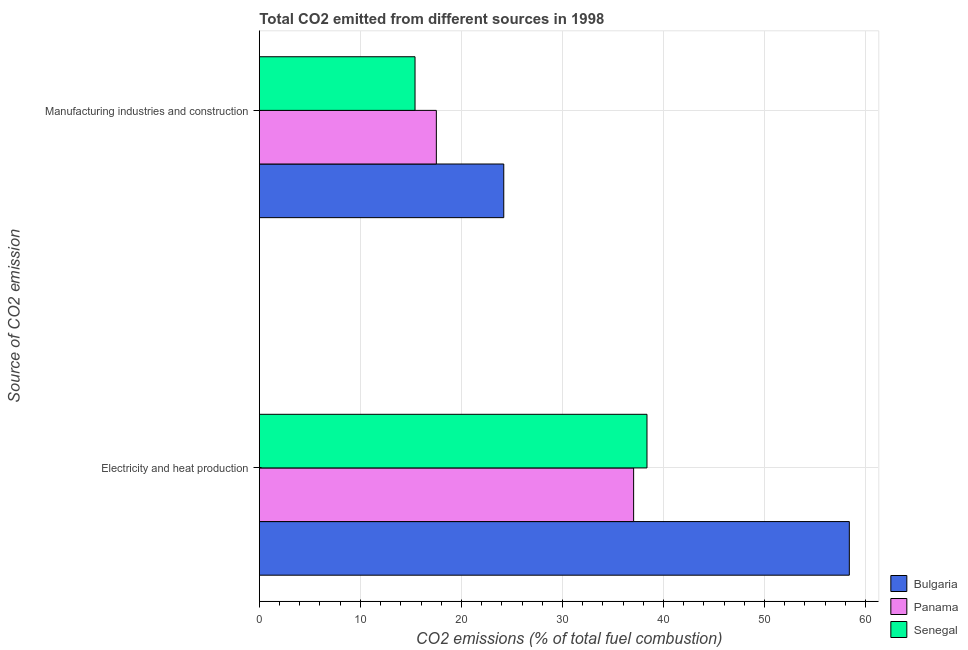Are the number of bars on each tick of the Y-axis equal?
Ensure brevity in your answer.  Yes. How many bars are there on the 2nd tick from the top?
Provide a succinct answer. 3. What is the label of the 2nd group of bars from the top?
Offer a very short reply. Electricity and heat production. What is the co2 emissions due to electricity and heat production in Senegal?
Provide a succinct answer. 38.36. Across all countries, what is the maximum co2 emissions due to electricity and heat production?
Provide a short and direct response. 58.39. Across all countries, what is the minimum co2 emissions due to manufacturing industries?
Your response must be concise. 15.41. In which country was the co2 emissions due to electricity and heat production maximum?
Your answer should be compact. Bulgaria. In which country was the co2 emissions due to manufacturing industries minimum?
Make the answer very short. Senegal. What is the total co2 emissions due to electricity and heat production in the graph?
Ensure brevity in your answer.  133.8. What is the difference between the co2 emissions due to electricity and heat production in Senegal and that in Panama?
Your response must be concise. 1.32. What is the difference between the co2 emissions due to manufacturing industries in Bulgaria and the co2 emissions due to electricity and heat production in Panama?
Keep it short and to the point. -12.85. What is the average co2 emissions due to manufacturing industries per country?
Give a very brief answer. 19.04. What is the difference between the co2 emissions due to manufacturing industries and co2 emissions due to electricity and heat production in Senegal?
Your answer should be very brief. -22.96. What is the ratio of the co2 emissions due to manufacturing industries in Panama to that in Senegal?
Offer a terse response. 1.14. In how many countries, is the co2 emissions due to electricity and heat production greater than the average co2 emissions due to electricity and heat production taken over all countries?
Provide a short and direct response. 1. What does the 1st bar from the top in Electricity and heat production represents?
Offer a very short reply. Senegal. What does the 1st bar from the bottom in Electricity and heat production represents?
Provide a succinct answer. Bulgaria. How many bars are there?
Offer a terse response. 6. How many countries are there in the graph?
Provide a succinct answer. 3. What is the difference between two consecutive major ticks on the X-axis?
Ensure brevity in your answer.  10. Are the values on the major ticks of X-axis written in scientific E-notation?
Ensure brevity in your answer.  No. How are the legend labels stacked?
Provide a succinct answer. Vertical. What is the title of the graph?
Your answer should be very brief. Total CO2 emitted from different sources in 1998. What is the label or title of the X-axis?
Provide a short and direct response. CO2 emissions (% of total fuel combustion). What is the label or title of the Y-axis?
Make the answer very short. Source of CO2 emission. What is the CO2 emissions (% of total fuel combustion) in Bulgaria in Electricity and heat production?
Provide a succinct answer. 58.39. What is the CO2 emissions (% of total fuel combustion) of Panama in Electricity and heat production?
Keep it short and to the point. 37.04. What is the CO2 emissions (% of total fuel combustion) of Senegal in Electricity and heat production?
Your answer should be very brief. 38.36. What is the CO2 emissions (% of total fuel combustion) in Bulgaria in Manufacturing industries and construction?
Your answer should be compact. 24.19. What is the CO2 emissions (% of total fuel combustion) in Panama in Manufacturing industries and construction?
Provide a succinct answer. 17.52. What is the CO2 emissions (% of total fuel combustion) of Senegal in Manufacturing industries and construction?
Offer a very short reply. 15.41. Across all Source of CO2 emission, what is the maximum CO2 emissions (% of total fuel combustion) of Bulgaria?
Your response must be concise. 58.39. Across all Source of CO2 emission, what is the maximum CO2 emissions (% of total fuel combustion) in Panama?
Your response must be concise. 37.04. Across all Source of CO2 emission, what is the maximum CO2 emissions (% of total fuel combustion) of Senegal?
Your answer should be very brief. 38.36. Across all Source of CO2 emission, what is the minimum CO2 emissions (% of total fuel combustion) of Bulgaria?
Keep it short and to the point. 24.19. Across all Source of CO2 emission, what is the minimum CO2 emissions (% of total fuel combustion) of Panama?
Your answer should be compact. 17.52. Across all Source of CO2 emission, what is the minimum CO2 emissions (% of total fuel combustion) in Senegal?
Your answer should be very brief. 15.41. What is the total CO2 emissions (% of total fuel combustion) in Bulgaria in the graph?
Offer a very short reply. 82.58. What is the total CO2 emissions (% of total fuel combustion) in Panama in the graph?
Provide a succinct answer. 54.56. What is the total CO2 emissions (% of total fuel combustion) of Senegal in the graph?
Your response must be concise. 53.77. What is the difference between the CO2 emissions (% of total fuel combustion) in Bulgaria in Electricity and heat production and that in Manufacturing industries and construction?
Keep it short and to the point. 34.2. What is the difference between the CO2 emissions (% of total fuel combustion) in Panama in Electricity and heat production and that in Manufacturing industries and construction?
Provide a short and direct response. 19.53. What is the difference between the CO2 emissions (% of total fuel combustion) in Senegal in Electricity and heat production and that in Manufacturing industries and construction?
Provide a short and direct response. 22.96. What is the difference between the CO2 emissions (% of total fuel combustion) in Bulgaria in Electricity and heat production and the CO2 emissions (% of total fuel combustion) in Panama in Manufacturing industries and construction?
Provide a succinct answer. 40.87. What is the difference between the CO2 emissions (% of total fuel combustion) in Bulgaria in Electricity and heat production and the CO2 emissions (% of total fuel combustion) in Senegal in Manufacturing industries and construction?
Ensure brevity in your answer.  42.98. What is the difference between the CO2 emissions (% of total fuel combustion) of Panama in Electricity and heat production and the CO2 emissions (% of total fuel combustion) of Senegal in Manufacturing industries and construction?
Your response must be concise. 21.64. What is the average CO2 emissions (% of total fuel combustion) of Bulgaria per Source of CO2 emission?
Your response must be concise. 41.29. What is the average CO2 emissions (% of total fuel combustion) of Panama per Source of CO2 emission?
Give a very brief answer. 27.28. What is the average CO2 emissions (% of total fuel combustion) of Senegal per Source of CO2 emission?
Your answer should be very brief. 26.89. What is the difference between the CO2 emissions (% of total fuel combustion) of Bulgaria and CO2 emissions (% of total fuel combustion) of Panama in Electricity and heat production?
Offer a terse response. 21.35. What is the difference between the CO2 emissions (% of total fuel combustion) in Bulgaria and CO2 emissions (% of total fuel combustion) in Senegal in Electricity and heat production?
Make the answer very short. 20.03. What is the difference between the CO2 emissions (% of total fuel combustion) in Panama and CO2 emissions (% of total fuel combustion) in Senegal in Electricity and heat production?
Offer a terse response. -1.32. What is the difference between the CO2 emissions (% of total fuel combustion) in Bulgaria and CO2 emissions (% of total fuel combustion) in Panama in Manufacturing industries and construction?
Make the answer very short. 6.67. What is the difference between the CO2 emissions (% of total fuel combustion) in Bulgaria and CO2 emissions (% of total fuel combustion) in Senegal in Manufacturing industries and construction?
Your answer should be very brief. 8.78. What is the difference between the CO2 emissions (% of total fuel combustion) in Panama and CO2 emissions (% of total fuel combustion) in Senegal in Manufacturing industries and construction?
Ensure brevity in your answer.  2.11. What is the ratio of the CO2 emissions (% of total fuel combustion) in Bulgaria in Electricity and heat production to that in Manufacturing industries and construction?
Give a very brief answer. 2.41. What is the ratio of the CO2 emissions (% of total fuel combustion) in Panama in Electricity and heat production to that in Manufacturing industries and construction?
Provide a succinct answer. 2.11. What is the ratio of the CO2 emissions (% of total fuel combustion) in Senegal in Electricity and heat production to that in Manufacturing industries and construction?
Your response must be concise. 2.49. What is the difference between the highest and the second highest CO2 emissions (% of total fuel combustion) in Bulgaria?
Offer a very short reply. 34.2. What is the difference between the highest and the second highest CO2 emissions (% of total fuel combustion) in Panama?
Your answer should be compact. 19.53. What is the difference between the highest and the second highest CO2 emissions (% of total fuel combustion) in Senegal?
Offer a very short reply. 22.96. What is the difference between the highest and the lowest CO2 emissions (% of total fuel combustion) in Bulgaria?
Your answer should be very brief. 34.2. What is the difference between the highest and the lowest CO2 emissions (% of total fuel combustion) in Panama?
Your answer should be very brief. 19.53. What is the difference between the highest and the lowest CO2 emissions (% of total fuel combustion) in Senegal?
Your answer should be very brief. 22.96. 